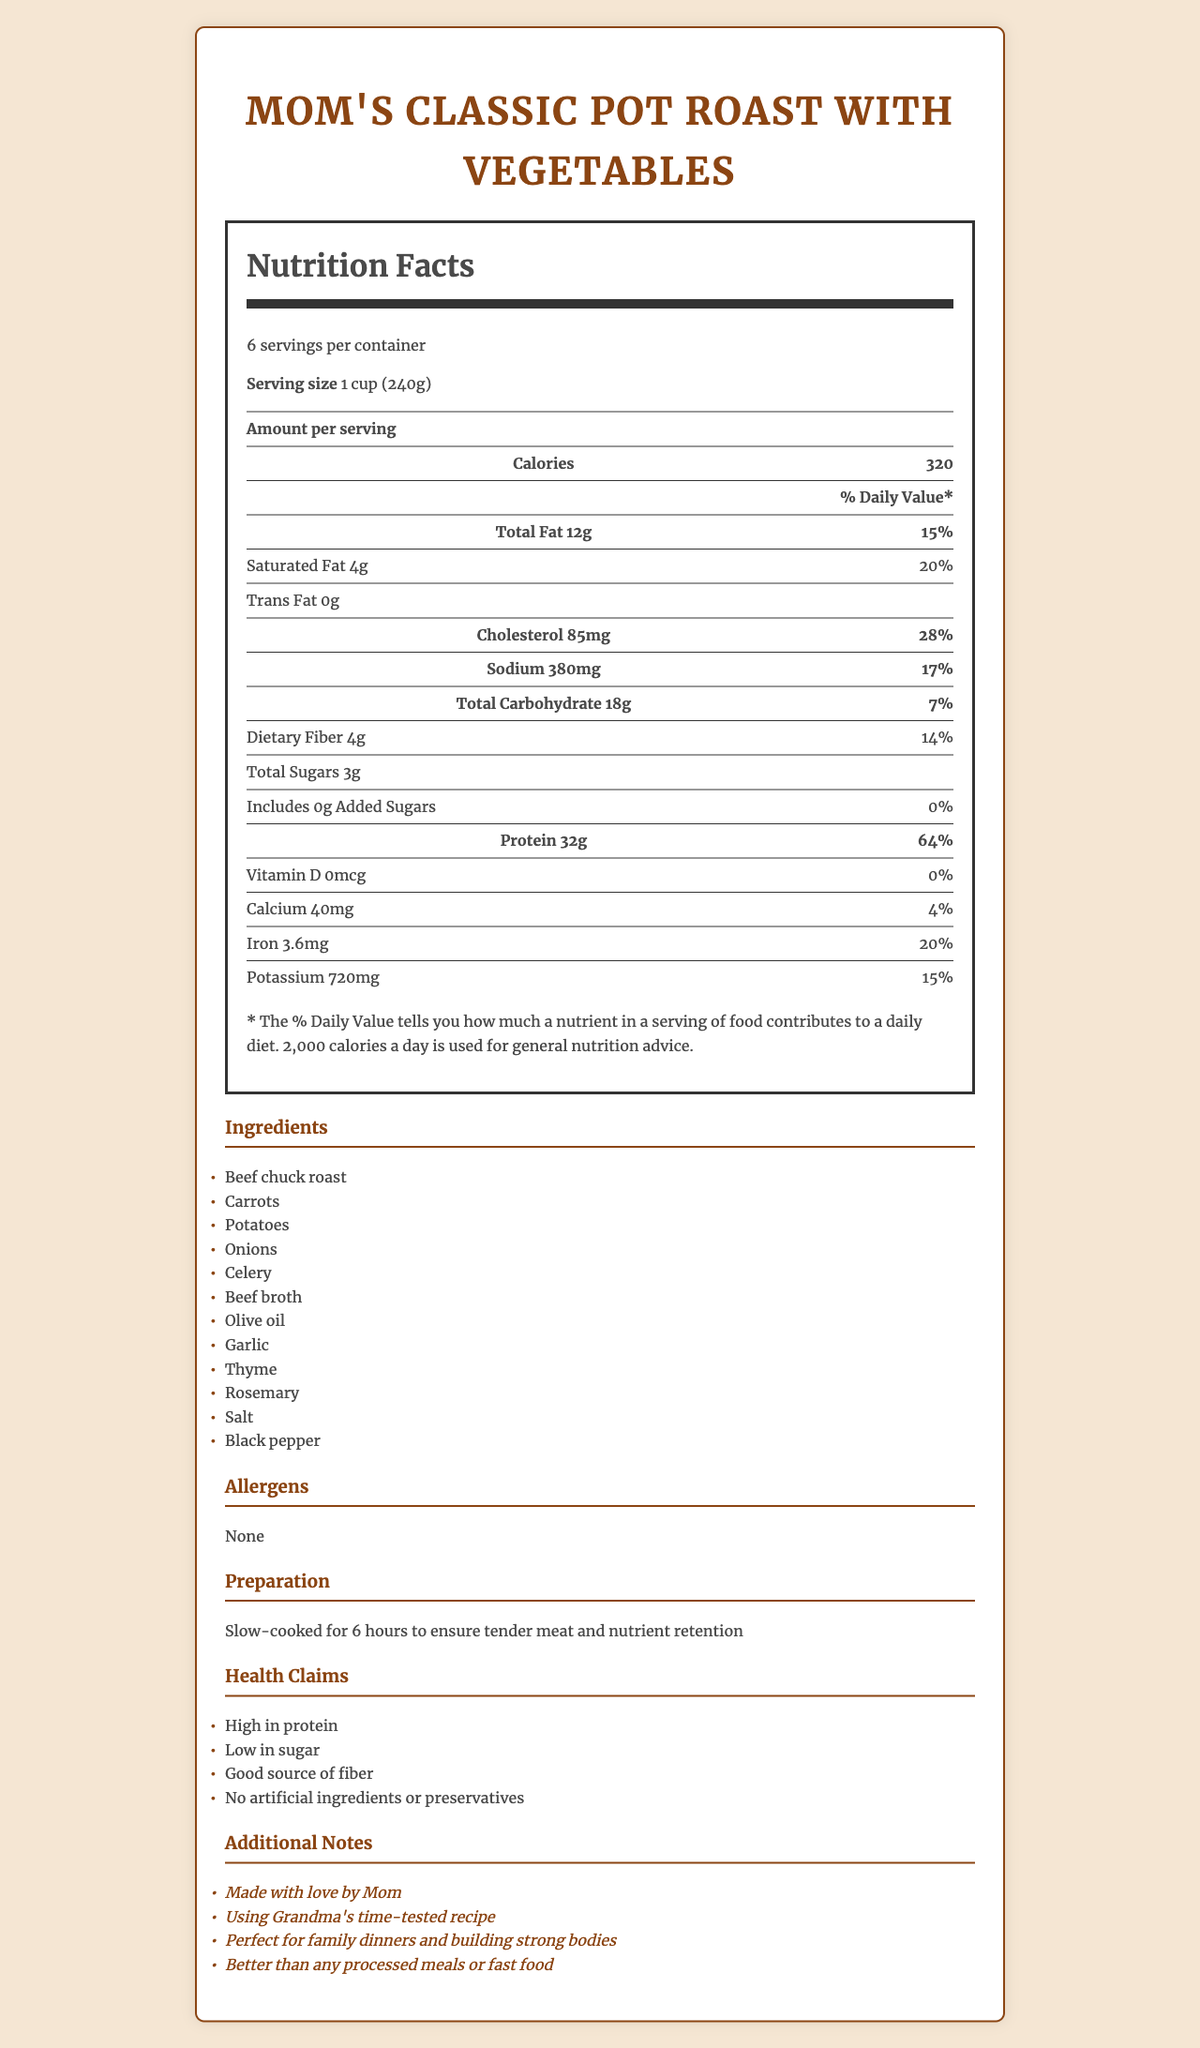what is the serving size? The document states the serving size explicitly as "1 cup (240g)".
Answer: 1 cup (240g) how many calories are in each serving? Under "Amount per serving," the document indicates 320 calories per serving.
Answer: 320 calories list three ingredients in the dish The document lists all ingredients, of which Beef chuck roast, Carrots, and Potatoes are three examples.
Answer: Beef chuck roast, Carrots, Potatoes what is the total amount of protein per serving? Under "Amount per serving," the document specifies that there are 32g of protein per serving.
Answer: 32g how much dietary fiber is in each serving? Under "Total Carbohydrate," the document mentions 4g of dietary fiber per serving.
Answer: 4g how many servings are there per container? The document specifies that there are 6 servings per container.
Answer: 6 servings what percentage of the daily value is provided by the sodium content per serving? The daily value percentage for sodium per serving is listed as 17%.
Answer: 17% how long should the pot roast be cooked to ensure tender meat? The preparation instructions state the pot roast should be slow-cooked for 6 hours.
Answer: 6 hours which of these is considered an allergen in the dish?
A. Beef
B. Celery
C. None The allergens section of the document states "None," indicating there are no allergens listed.
Answer: C. None how much cholesterol is in each serving? A. 45mg B. 85mg C. 120mg D. 200mg The "Cholesterol" section lists 85mg of cholesterol per serving.
Answer: B. 85mg is there any added sugar in the dish? The document specifies that there are 0g of added sugars.
Answer: No are there any artificial ingredients or preservatives in the dish? One of the health claims states "No artificial ingredients or preservatives."
Answer: No summarize the key takeaways from the document. The document provides detailed nutrition facts, ingredients, preparation instructions, health claims, and additional notes, emphasizing that the meal is high in protein, low in sugar, made with natural ingredients, and prepared with care.
Answer: Mom's Classic Pot Roast with Vegetables is a nutritious home-cooked meal with a serving size of 1 cup (240g) and 6 servings per container. Each serving contains 320 calories, 32g of protein, and only 3g of total sugars with no added sugars. It is high in protein, low in sugar, and a good source of fiber. The dish is prepared using natural ingredients and slow-cooked for 6 hours with no artificial ingredients or preservatives. It emphasizes traditional family values and healthy eating. which company produced this dish? The document does not provide any branding or company information.
Answer: Not enough information 